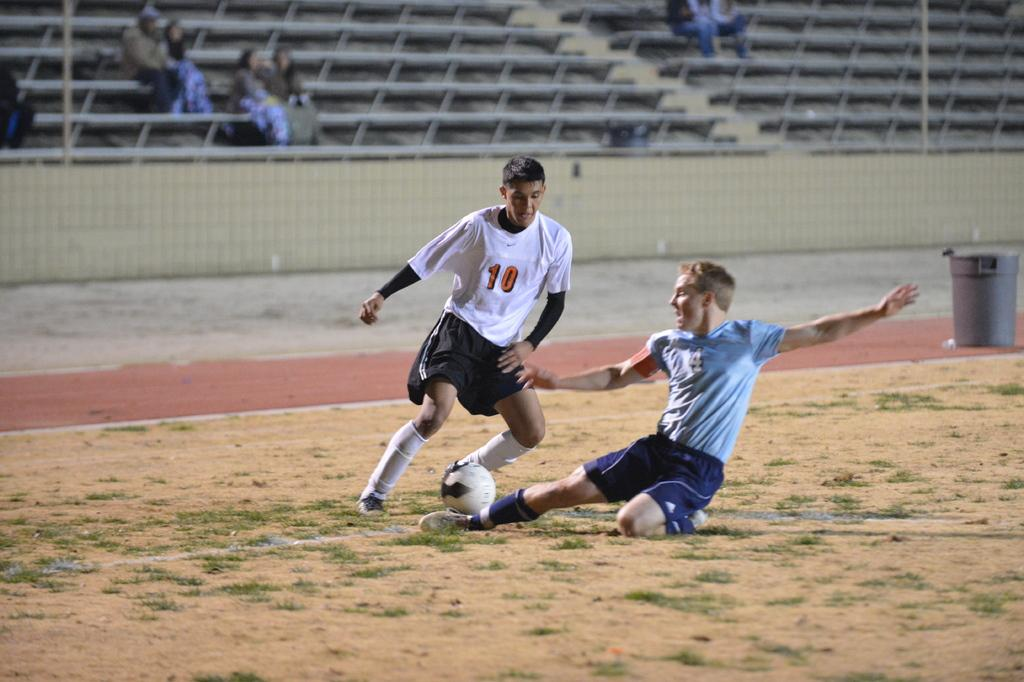What type of venue is depicted in the image? There is a stadium in the image. What activity are the two people engaged in? Two people are playing with a football in the image. What type of question is being asked by the football in the image? There is no football asking a question in the image; it is a physical object being played with by two people. 